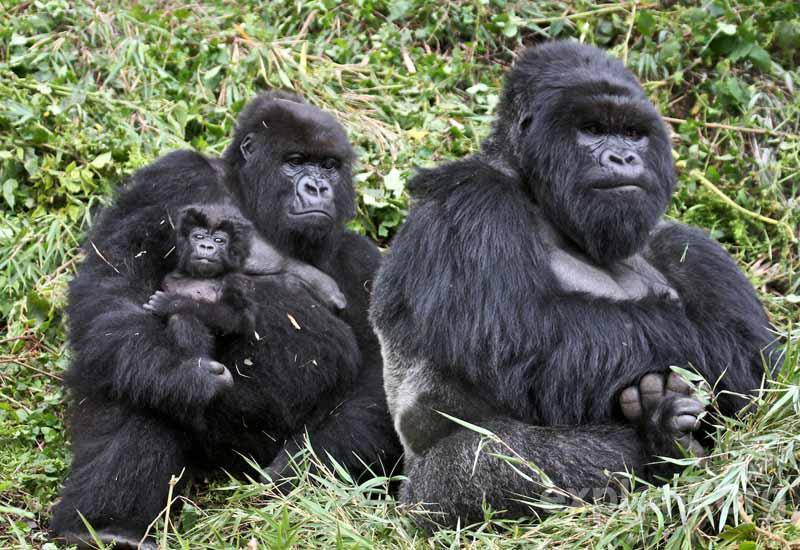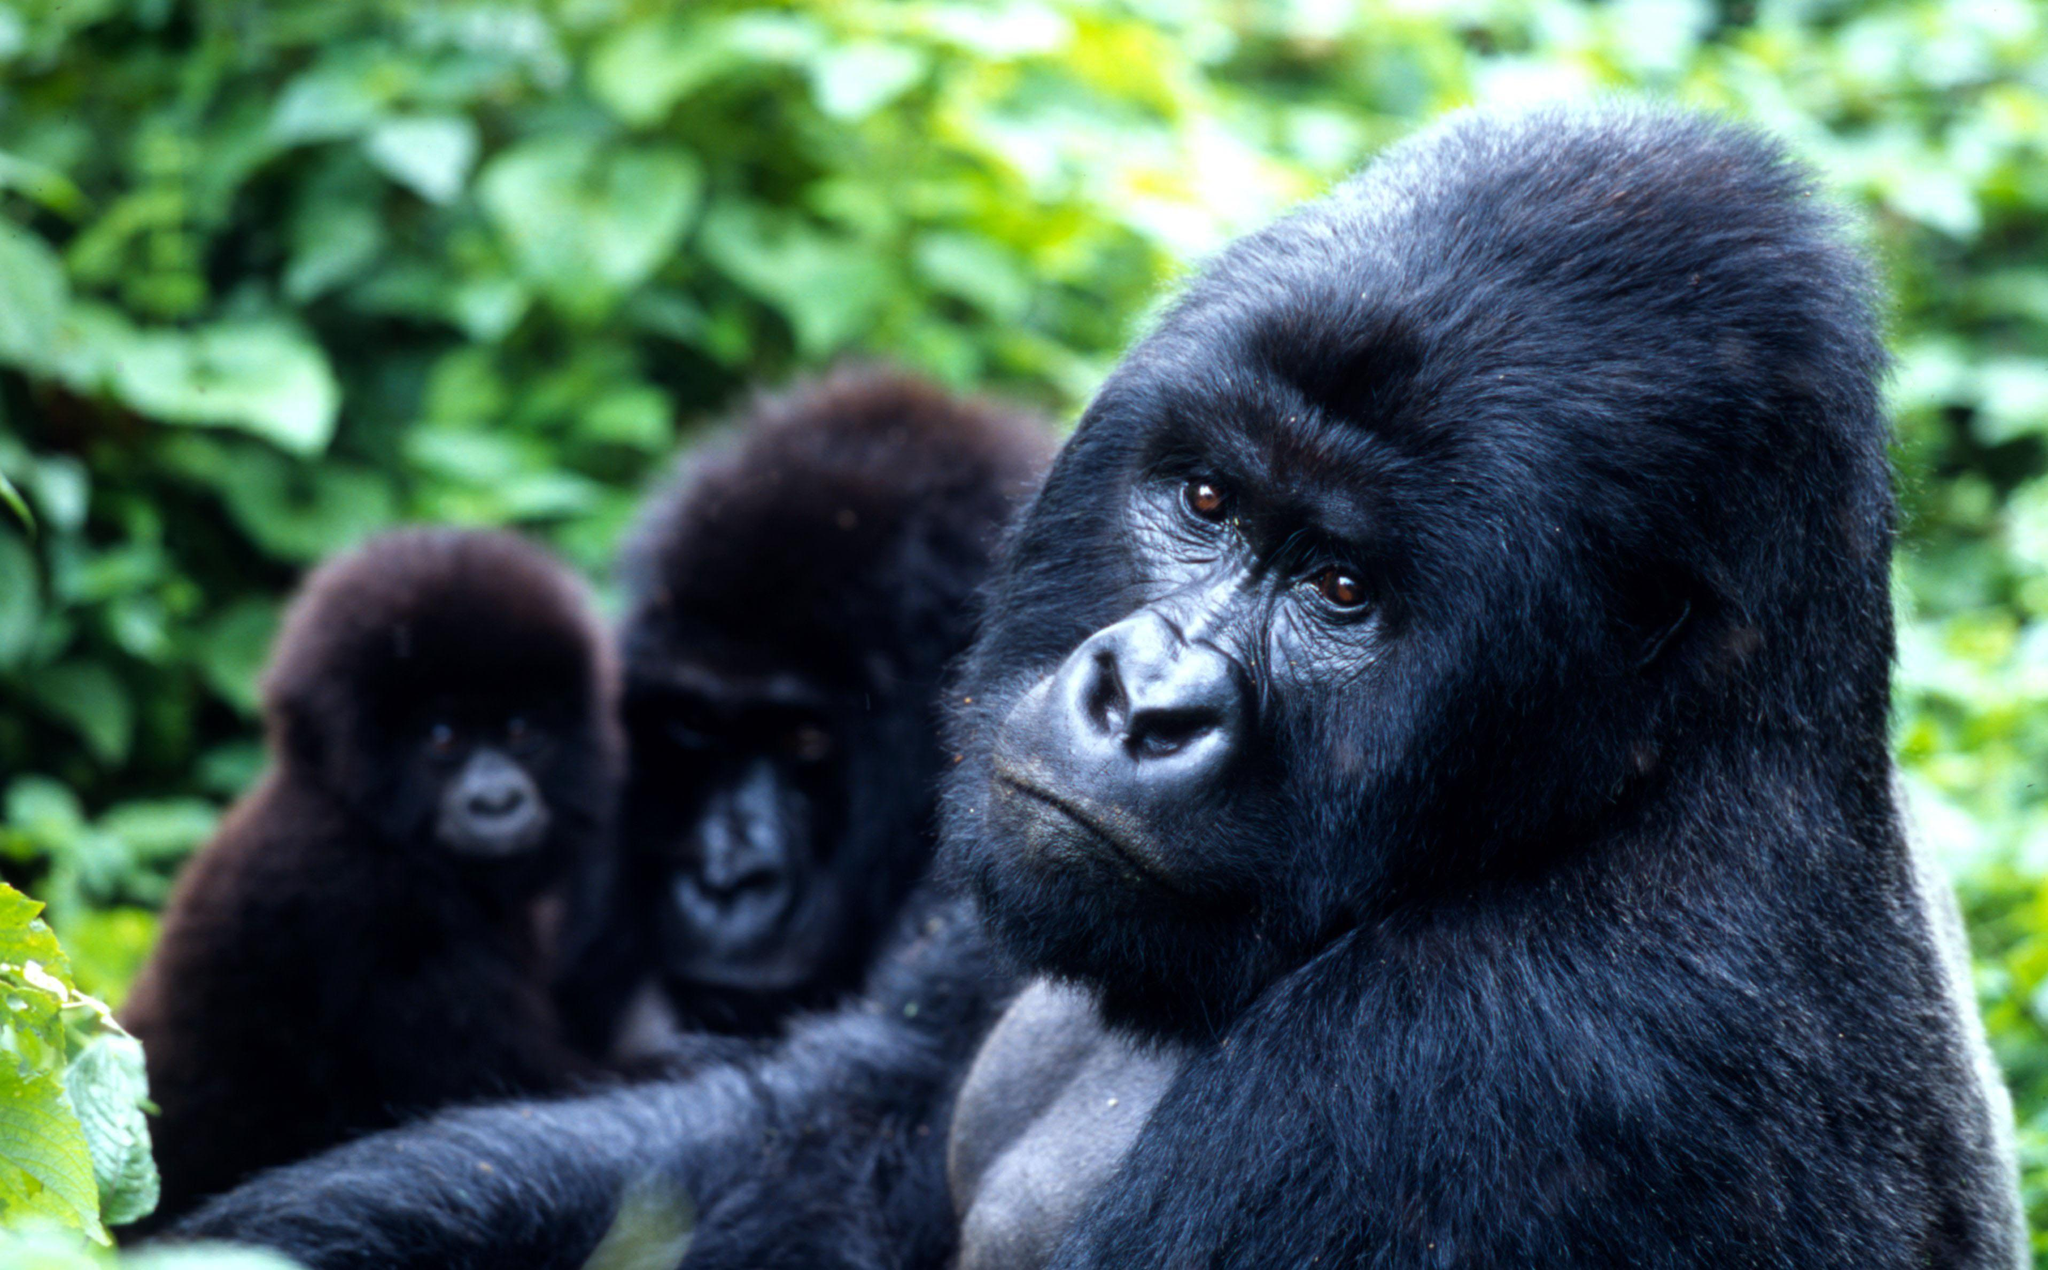The first image is the image on the left, the second image is the image on the right. For the images shown, is this caption "There are no more than six gorillas in total." true? Answer yes or no. Yes. The first image is the image on the left, the second image is the image on the right. For the images shown, is this caption "The right image contains no more than three gorillas and includes a furry young gorilla, and the left image shows a close family group of gorillas facing forward." true? Answer yes or no. Yes. 